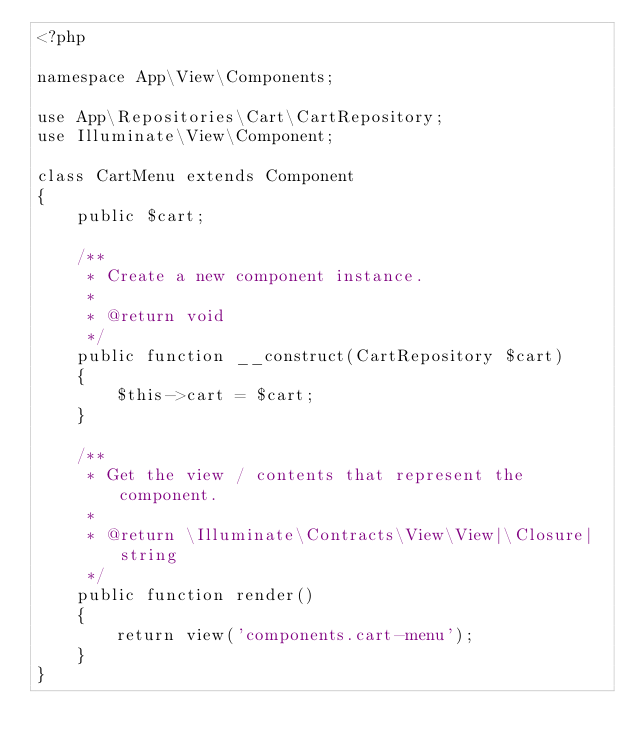<code> <loc_0><loc_0><loc_500><loc_500><_PHP_><?php

namespace App\View\Components;

use App\Repositories\Cart\CartRepository;
use Illuminate\View\Component;

class CartMenu extends Component
{
    public $cart;

    /**
     * Create a new component instance.
     *
     * @return void
     */
    public function __construct(CartRepository $cart)
    {
        $this->cart = $cart;
    }

    /**
     * Get the view / contents that represent the component.
     *
     * @return \Illuminate\Contracts\View\View|\Closure|string
     */
    public function render()
    {
        return view('components.cart-menu');
    }
}
</code> 